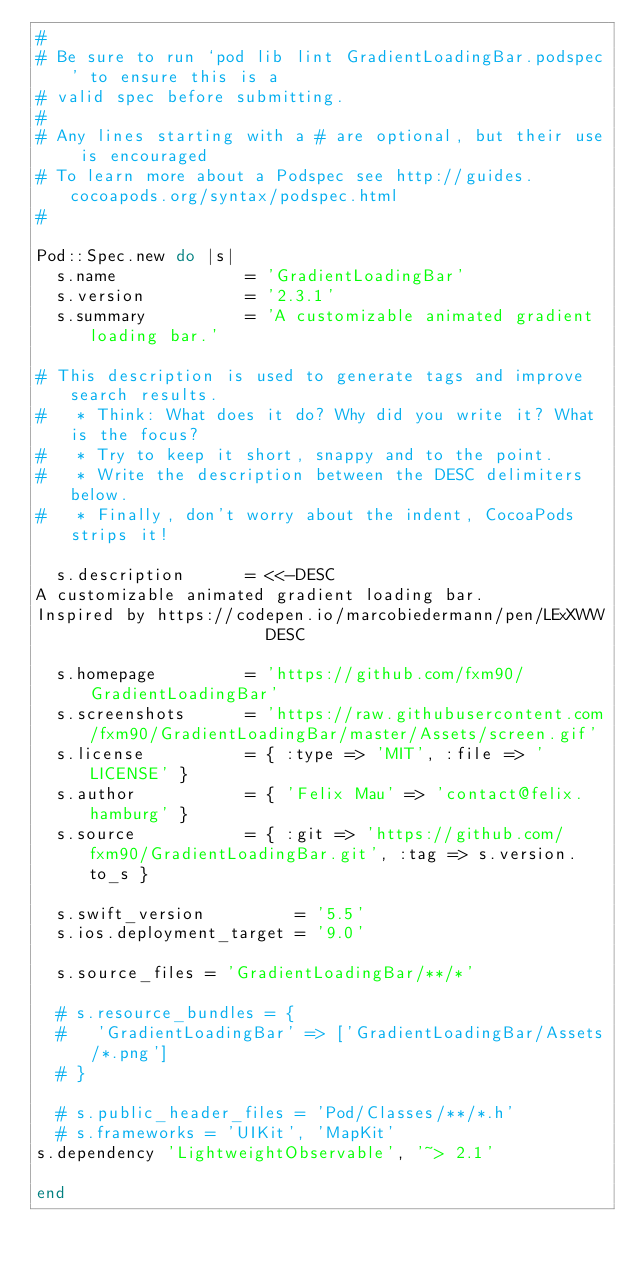Convert code to text. <code><loc_0><loc_0><loc_500><loc_500><_Ruby_>#
# Be sure to run `pod lib lint GradientLoadingBar.podspec' to ensure this is a
# valid spec before submitting.
#
# Any lines starting with a # are optional, but their use is encouraged
# To learn more about a Podspec see http://guides.cocoapods.org/syntax/podspec.html
#

Pod::Spec.new do |s|
  s.name             = 'GradientLoadingBar'
  s.version          = '2.3.1'
  s.summary          = 'A customizable animated gradient loading bar.'

# This description is used to generate tags and improve search results.
#   * Think: What does it do? Why did you write it? What is the focus?
#   * Try to keep it short, snappy and to the point.
#   * Write the description between the DESC delimiters below.
#   * Finally, don't worry about the indent, CocoaPods strips it!

  s.description      = <<-DESC
A customizable animated gradient loading bar.
Inspired by https://codepen.io/marcobiedermann/pen/LExXWW
                       DESC

  s.homepage         = 'https://github.com/fxm90/GradientLoadingBar'
  s.screenshots      = 'https://raw.githubusercontent.com/fxm90/GradientLoadingBar/master/Assets/screen.gif'
  s.license          = { :type => 'MIT', :file => 'LICENSE' }
  s.author           = { 'Felix Mau' => 'contact@felix.hamburg' }
  s.source           = { :git => 'https://github.com/fxm90/GradientLoadingBar.git', :tag => s.version.to_s }

  s.swift_version         = '5.5'
  s.ios.deployment_target = '9.0'

  s.source_files = 'GradientLoadingBar/**/*'

  # s.resource_bundles = {
  #   'GradientLoadingBar' => ['GradientLoadingBar/Assets/*.png']
  # }

  # s.public_header_files = 'Pod/Classes/**/*.h'
  # s.frameworks = 'UIKit', 'MapKit'
s.dependency 'LightweightObservable', '~> 2.1'

end
</code> 